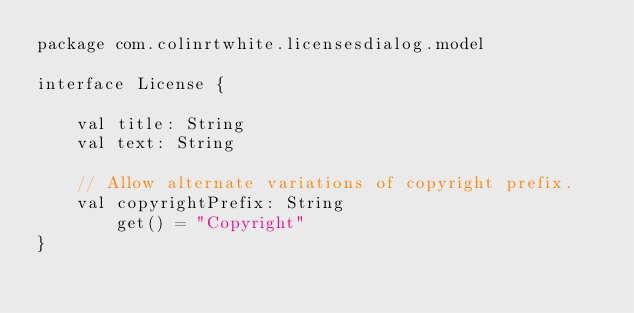Convert code to text. <code><loc_0><loc_0><loc_500><loc_500><_Kotlin_>package com.colinrtwhite.licensesdialog.model

interface License {

	val title: String
	val text: String

	// Allow alternate variations of copyright prefix.
	val copyrightPrefix: String
		get() = "Copyright"
}</code> 